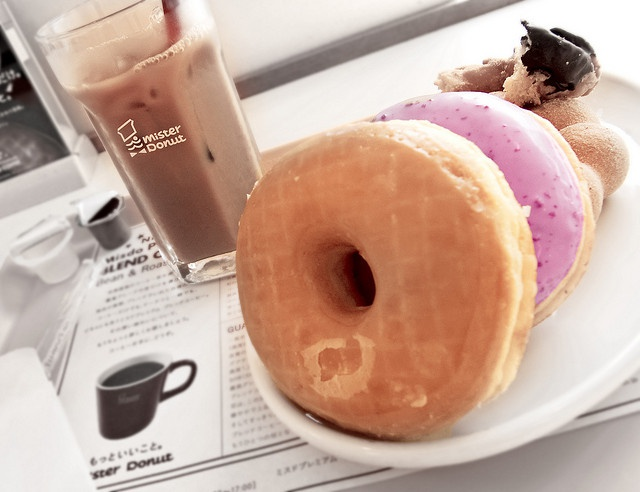Describe the objects in this image and their specific colors. I can see donut in darkgray, salmon, and tan tones, dining table in darkgray and lightgray tones, cup in darkgray, brown, tan, and lightgray tones, donut in darkgray, lightpink, white, pink, and tan tones, and cake in darkgray, black, brown, gray, and maroon tones in this image. 